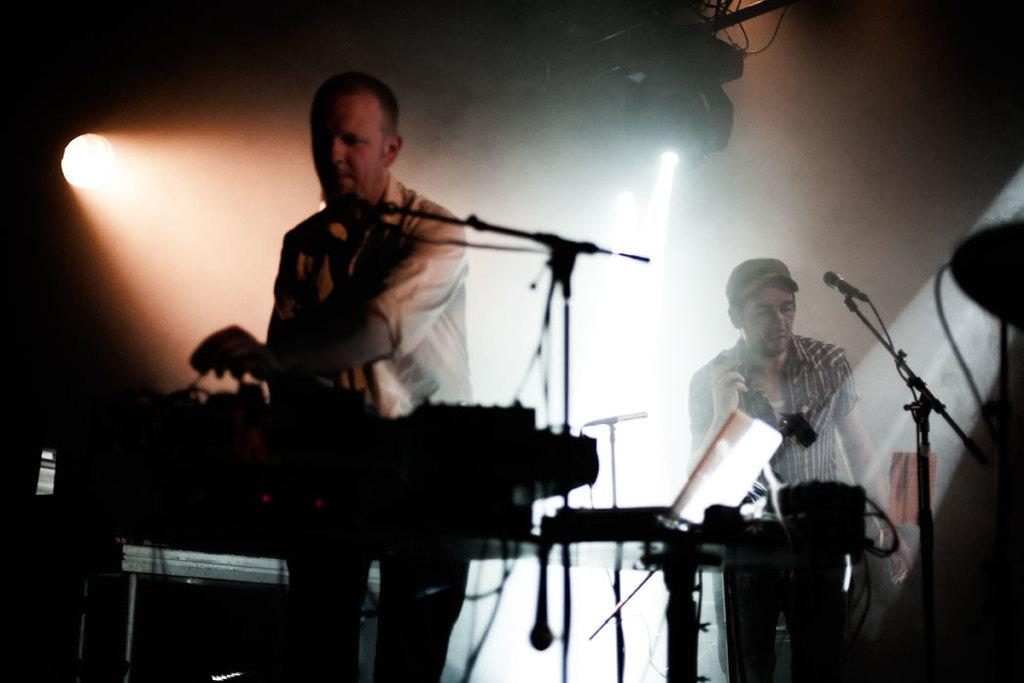What activity are the people in the image engaged in? The people in the image are musicians performing. What objects are being used by the musicians? There are musical instruments in the image. What can be seen at the top of the image of the image? There are lights visible at the top of the image. What type of lettuce is being used as a prop by the musicians in the image? There is no lettuce present in the image; the musicians are using musical instruments. Can you see a horse in the image? No, there is no horse present in the image. 